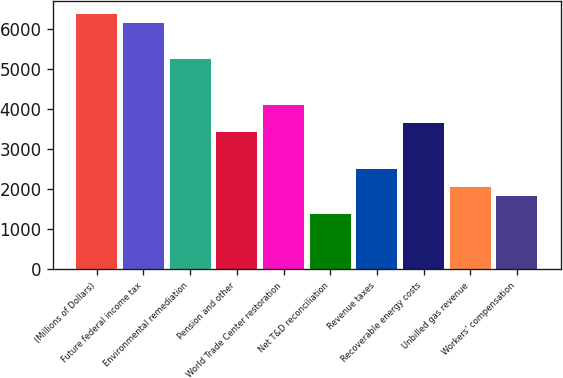Convert chart. <chart><loc_0><loc_0><loc_500><loc_500><bar_chart><fcel>(Millions of Dollars)<fcel>Future federal income tax<fcel>Environmental remediation<fcel>Pension and other<fcel>World Trade Center restoration<fcel>Net T&D reconciliation<fcel>Revenue taxes<fcel>Recoverable energy costs<fcel>Unbilled gas revenue<fcel>Workers' compensation<nl><fcel>6386.4<fcel>6158.6<fcel>5247.4<fcel>3425<fcel>4108.4<fcel>1374.8<fcel>2513.8<fcel>3652.8<fcel>2058.2<fcel>1830.4<nl></chart> 